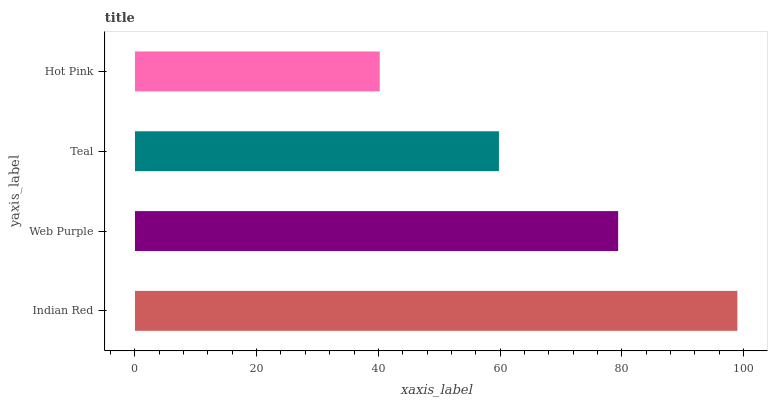Is Hot Pink the minimum?
Answer yes or no. Yes. Is Indian Red the maximum?
Answer yes or no. Yes. Is Web Purple the minimum?
Answer yes or no. No. Is Web Purple the maximum?
Answer yes or no. No. Is Indian Red greater than Web Purple?
Answer yes or no. Yes. Is Web Purple less than Indian Red?
Answer yes or no. Yes. Is Web Purple greater than Indian Red?
Answer yes or no. No. Is Indian Red less than Web Purple?
Answer yes or no. No. Is Web Purple the high median?
Answer yes or no. Yes. Is Teal the low median?
Answer yes or no. Yes. Is Indian Red the high median?
Answer yes or no. No. Is Indian Red the low median?
Answer yes or no. No. 